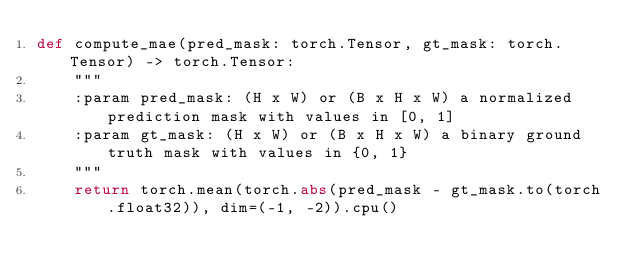<code> <loc_0><loc_0><loc_500><loc_500><_Python_>def compute_mae(pred_mask: torch.Tensor, gt_mask: torch.Tensor) -> torch.Tensor:
    """
    :param pred_mask: (H x W) or (B x H x W) a normalized prediction mask with values in [0, 1]
    :param gt_mask: (H x W) or (B x H x W) a binary ground truth mask with values in {0, 1}
    """
    return torch.mean(torch.abs(pred_mask - gt_mask.to(torch.float32)), dim=(-1, -2)).cpu()
</code> 